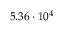Convert formula to latex. <formula><loc_0><loc_0><loc_500><loc_500>5 . 3 6 \cdot 1 0 ^ { 4 }</formula> 